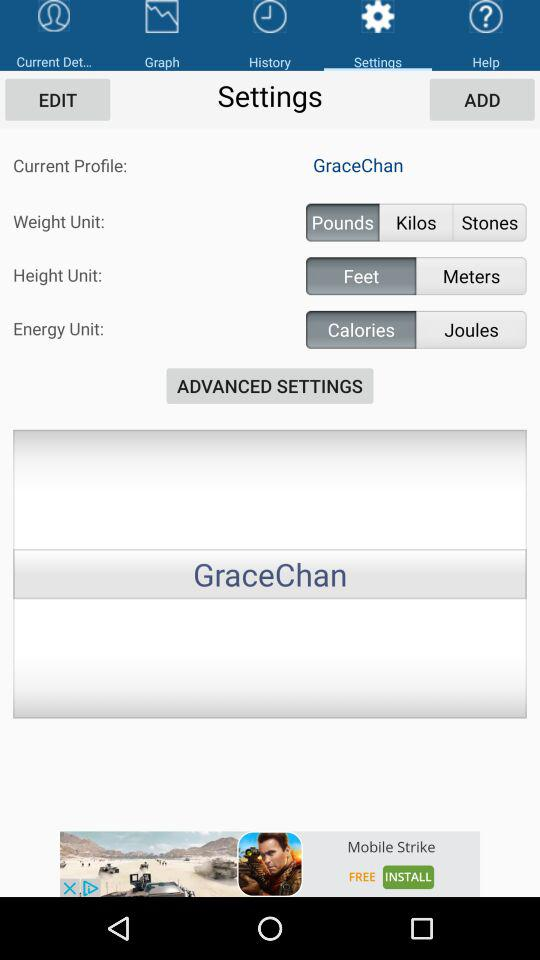What is the name of the user? The name of the user is Grace Chan. 